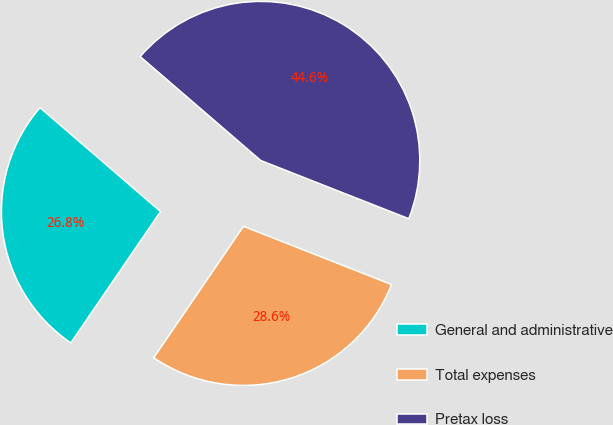Convert chart to OTSL. <chart><loc_0><loc_0><loc_500><loc_500><pie_chart><fcel>General and administrative<fcel>Total expenses<fcel>Pretax loss<nl><fcel>26.79%<fcel>28.57%<fcel>44.64%<nl></chart> 